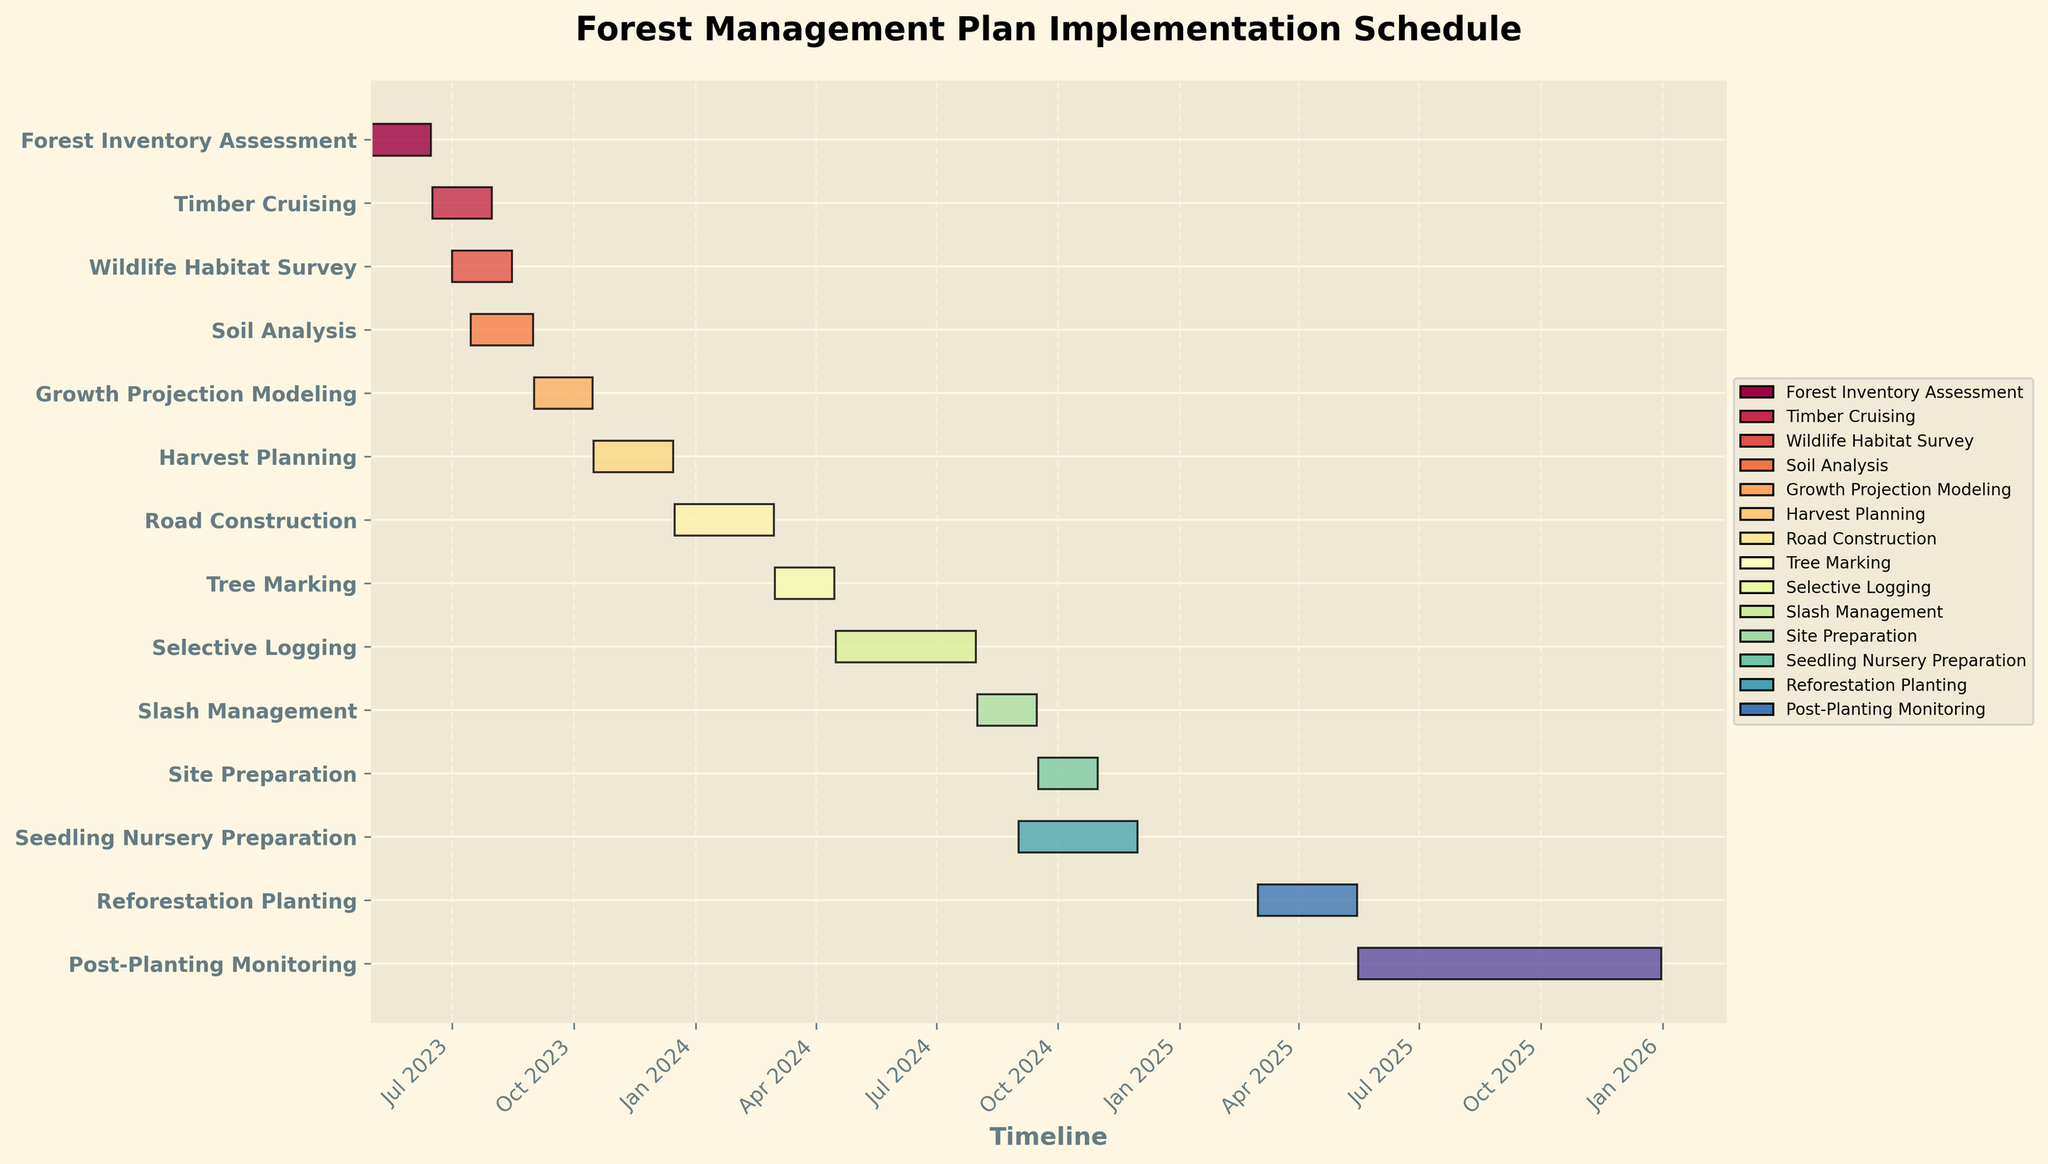When does the Harvest Planning task start and end? The chart shows the start and end dates for each task. For Harvest Planning, it starts on 2023-10-16 and ends on 2023-12-15.
Answer: 2023-10-16 and 2023-12-15 How long does the Wildlife Habitat Survey take to complete? To determine the duration, subtract the start date from the end date for the Wildlife Habitat Survey task. From 2023-07-01 to 2023-08-15, it takes 45 days.
Answer: 45 days Which task takes place concurrently with Site Preparation? Look at the timeline intervals and identify overlapping periods for Site Preparation (2024-09-16 to 2024-10-31). The Seedling Nursery Preparation task also overlaps within this period (2024-09-01 to 2024-11-30).
Answer: Seedling Nursery Preparation What is the title of the chart? The title of the chart is displayed at the top of the figure. It reads: "Forest Management Plan Implementation Schedule".
Answer: Forest Management Plan Implementation Schedule How many tasks are scheduled to begin in the year 2023? Count the tasks with start dates in 2023. These include Forest Inventory Assessment, Timber Cruising, Wildlife Habitat Survey, Soil Analysis, Growth Projection Modeling, Harvest Planning, and Road Construction.
Answer: 7 tasks Which task has the longest duration? Check the duration of each task. Selective Logging (2024-04-16 to 2024-07-31) has the longest duration, taking 107 days.
Answer: Selective Logging Are there any gaps between the completion of Tree Marking and the start of Selective Logging? Compare the end date of Tree Marking (2024-04-15) with the start date of Selective Logging (2024-04-16). There are no gaps as Selective Logging starts immediately after Tree Marking ends.
Answer: No When does the Reforestation Planting task start? According to the chart, the Reforestation Planting task starts on 2025-03-01.
Answer: 2025-03-01 During what time of the year will Slash Management be performed? The chart shows the dates for Slash Management as from 2024-08-01 to 2024-09-15. It takes place during late summer.
Answer: Late summer How many tasks are performed concurrently with the Soil Analysis? Check overlapping periods with Soil Analysis (2023-07-15 to 2023-08-31). Wildlife Habitat Survey (2023-07-01 to 2023-08-15) overlaps with this task.
Answer: 1 task 